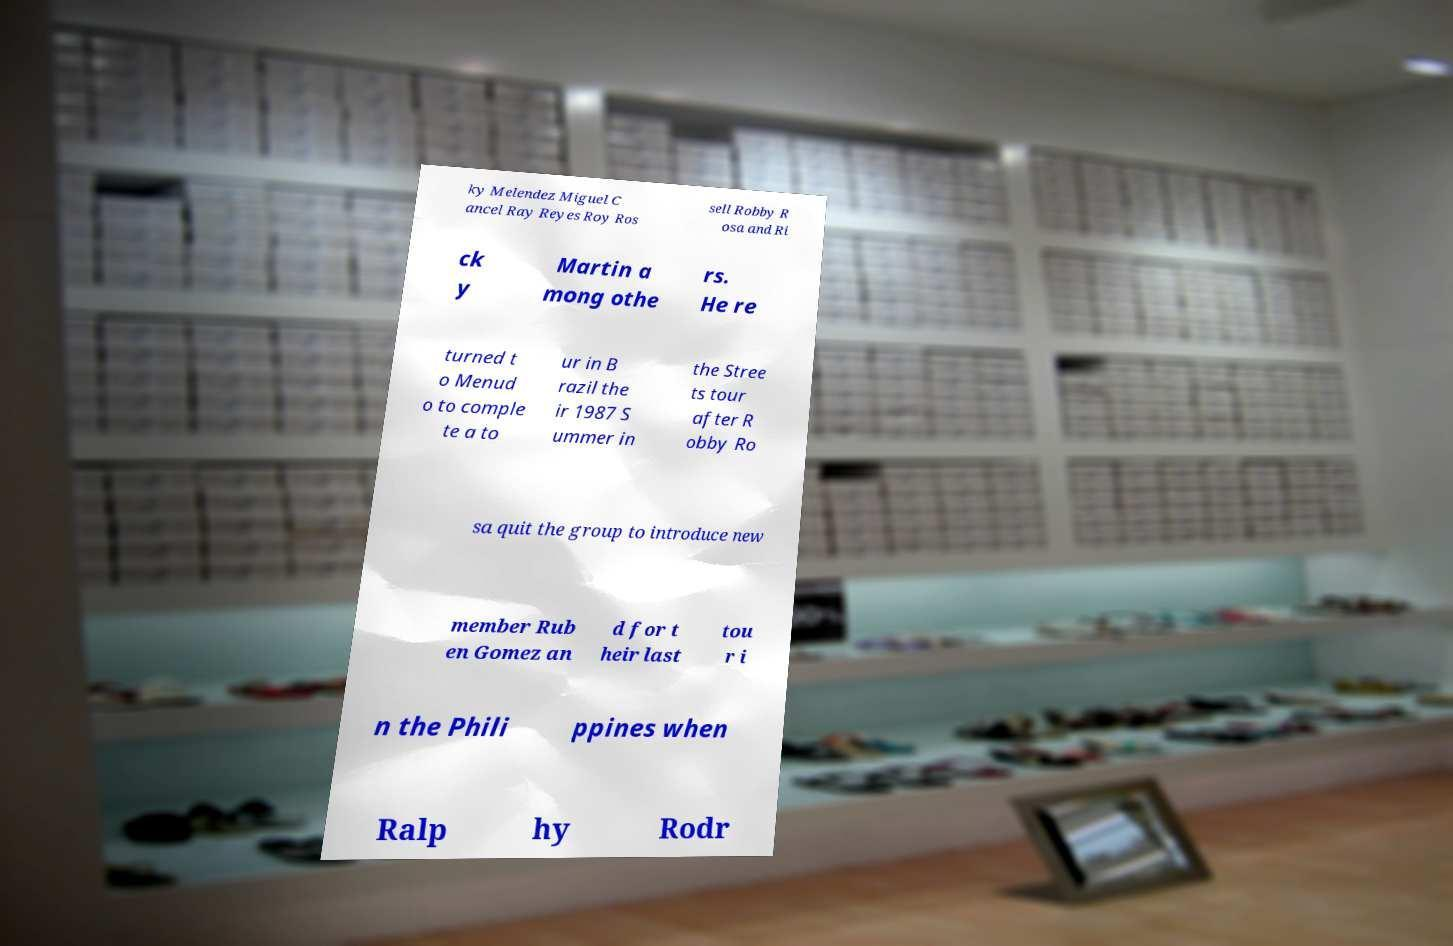I need the written content from this picture converted into text. Can you do that? ky Melendez Miguel C ancel Ray Reyes Roy Ros sell Robby R osa and Ri ck y Martin a mong othe rs. He re turned t o Menud o to comple te a to ur in B razil the ir 1987 S ummer in the Stree ts tour after R obby Ro sa quit the group to introduce new member Rub en Gomez an d for t heir last tou r i n the Phili ppines when Ralp hy Rodr 